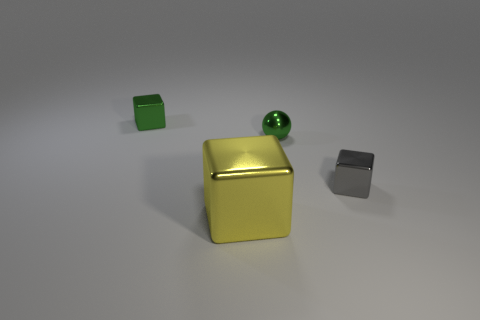There is a object that is the same color as the shiny sphere; what shape is it?
Provide a short and direct response. Cube. There is a tiny green metallic thing that is on the right side of the shiny block in front of the metal cube that is on the right side of the small green ball; what shape is it?
Make the answer very short. Sphere. Are there the same number of gray metallic cubes left of the tiny ball and small green metal spheres?
Offer a very short reply. No. The shiny object that is the same color as the sphere is what size?
Ensure brevity in your answer.  Small. Does the big yellow metallic thing have the same shape as the tiny gray thing?
Make the answer very short. Yes. How many things are either objects right of the small ball or yellow shiny cubes?
Provide a short and direct response. 2. Is the number of tiny green balls behind the green shiny sphere the same as the number of small green things that are in front of the large yellow metal object?
Your response must be concise. Yes. Does the shiny block behind the small gray metallic object have the same size as the object that is on the right side of the green ball?
Offer a terse response. Yes. What number of spheres are either tiny green metal objects or large things?
Give a very brief answer. 1. How many rubber objects are small green spheres or gray things?
Your answer should be very brief. 0. 